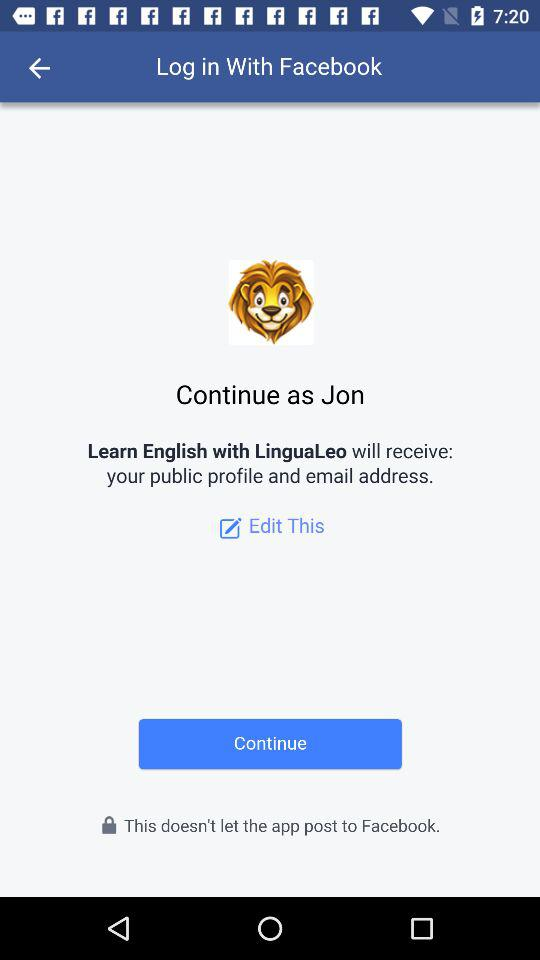What application is asking for permission? The application asking for permission is "Learn English with LinguaLeo". 